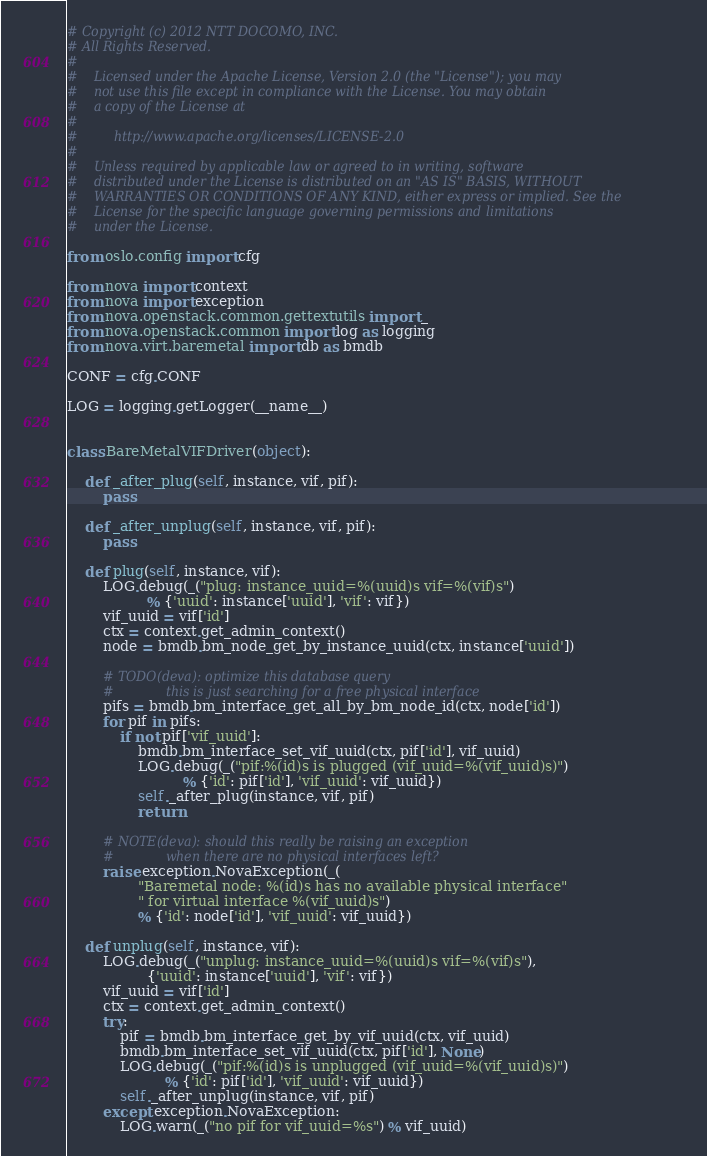Convert code to text. <code><loc_0><loc_0><loc_500><loc_500><_Python_># Copyright (c) 2012 NTT DOCOMO, INC.
# All Rights Reserved.
#
#    Licensed under the Apache License, Version 2.0 (the "License"); you may
#    not use this file except in compliance with the License. You may obtain
#    a copy of the License at
#
#         http://www.apache.org/licenses/LICENSE-2.0
#
#    Unless required by applicable law or agreed to in writing, software
#    distributed under the License is distributed on an "AS IS" BASIS, WITHOUT
#    WARRANTIES OR CONDITIONS OF ANY KIND, either express or implied. See the
#    License for the specific language governing permissions and limitations
#    under the License.

from oslo.config import cfg

from nova import context
from nova import exception
from nova.openstack.common.gettextutils import _
from nova.openstack.common import log as logging
from nova.virt.baremetal import db as bmdb

CONF = cfg.CONF

LOG = logging.getLogger(__name__)


class BareMetalVIFDriver(object):

    def _after_plug(self, instance, vif, pif):
        pass

    def _after_unplug(self, instance, vif, pif):
        pass

    def plug(self, instance, vif):
        LOG.debug(_("plug: instance_uuid=%(uuid)s vif=%(vif)s")
                  % {'uuid': instance['uuid'], 'vif': vif})
        vif_uuid = vif['id']
        ctx = context.get_admin_context()
        node = bmdb.bm_node_get_by_instance_uuid(ctx, instance['uuid'])

        # TODO(deva): optimize this database query
        #             this is just searching for a free physical interface
        pifs = bmdb.bm_interface_get_all_by_bm_node_id(ctx, node['id'])
        for pif in pifs:
            if not pif['vif_uuid']:
                bmdb.bm_interface_set_vif_uuid(ctx, pif['id'], vif_uuid)
                LOG.debug(_("pif:%(id)s is plugged (vif_uuid=%(vif_uuid)s)")
                          % {'id': pif['id'], 'vif_uuid': vif_uuid})
                self._after_plug(instance, vif, pif)
                return

        # NOTE(deva): should this really be raising an exception
        #             when there are no physical interfaces left?
        raise exception.NovaException(_(
                "Baremetal node: %(id)s has no available physical interface"
                " for virtual interface %(vif_uuid)s")
                % {'id': node['id'], 'vif_uuid': vif_uuid})

    def unplug(self, instance, vif):
        LOG.debug(_("unplug: instance_uuid=%(uuid)s vif=%(vif)s"),
                  {'uuid': instance['uuid'], 'vif': vif})
        vif_uuid = vif['id']
        ctx = context.get_admin_context()
        try:
            pif = bmdb.bm_interface_get_by_vif_uuid(ctx, vif_uuid)
            bmdb.bm_interface_set_vif_uuid(ctx, pif['id'], None)
            LOG.debug(_("pif:%(id)s is unplugged (vif_uuid=%(vif_uuid)s)")
                      % {'id': pif['id'], 'vif_uuid': vif_uuid})
            self._after_unplug(instance, vif, pif)
        except exception.NovaException:
            LOG.warn(_("no pif for vif_uuid=%s") % vif_uuid)
</code> 